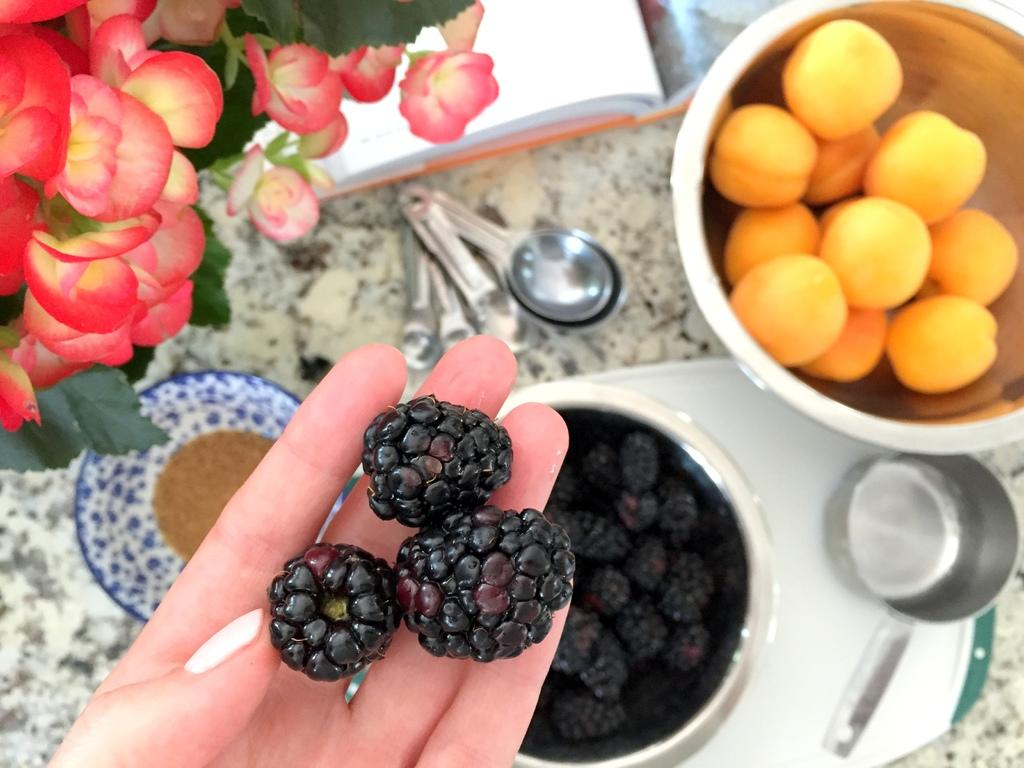What is on the person's hand in the image? There are blackberries on the person's hand. What type of plant can be seen in the image? There is a plant with flowers in the image. What is in the bowl on the table? There is a bowl of blackberries on the table. What other food items are on the table? There are food items on the table, but the specific items are not mentioned in the facts. What is the book on the table used for? The purpose of the book on the table is not mentioned in the facts. What is the measuring spoon used for? The measuring spoon on the table is likely used for measuring ingredients, but the specific use is not mentioned in the facts. What type of cable is connected to the blackberries in the image? There is no cable connected to the blackberries in the image. What causes the curve in the plant's stem in the image? The facts do not mention any curves in the plant's stem, nor do they provide information about the cause of such a curve. 